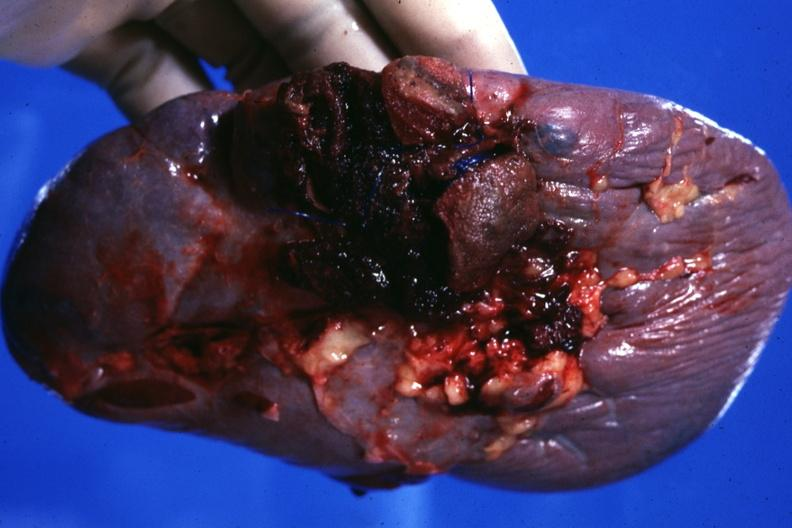s hematologic present?
Answer the question using a single word or phrase. Yes 